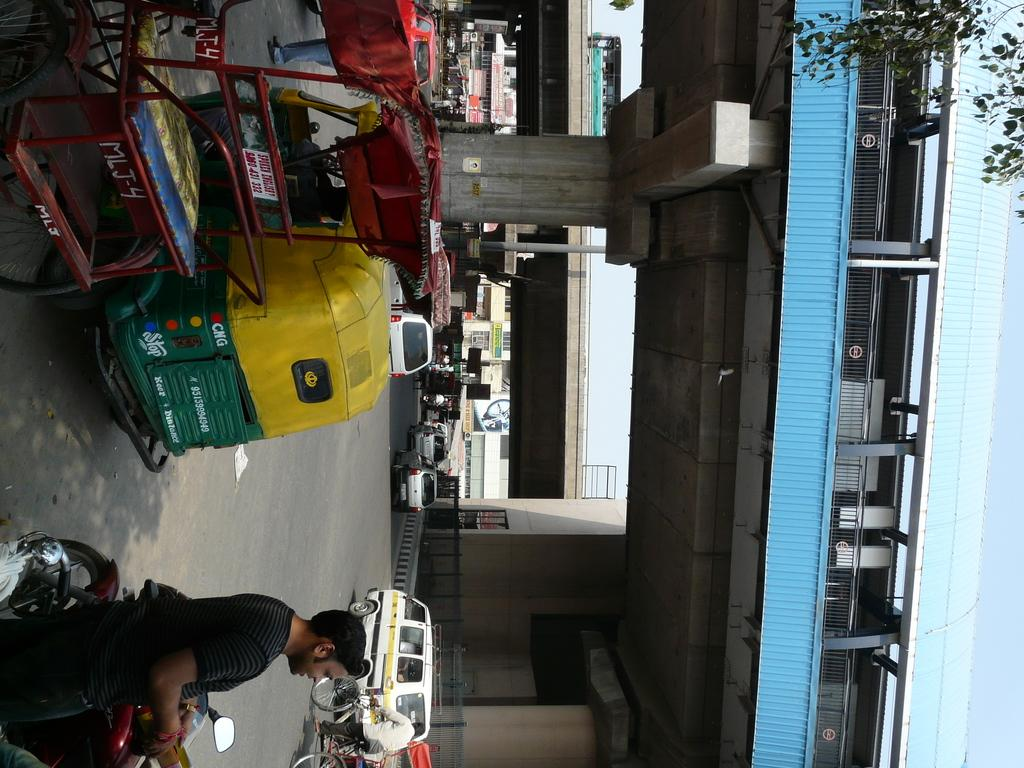What can be seen on the road in the image? There are vehicles on the road in the image. What are the people near the vehicles doing? There are persons standing near the vehicles and persons riding vehicles in the image. What type of structure is present in the image? There is a bridge in the image. Can you describe the location of the vehicle on the bridge? There is a vehicle on the bridge in the image. What type of rock is providing shade for the vehicles on the bridge? There is no rock present in the image, nor is there any indication of shade being provided for the vehicles. 